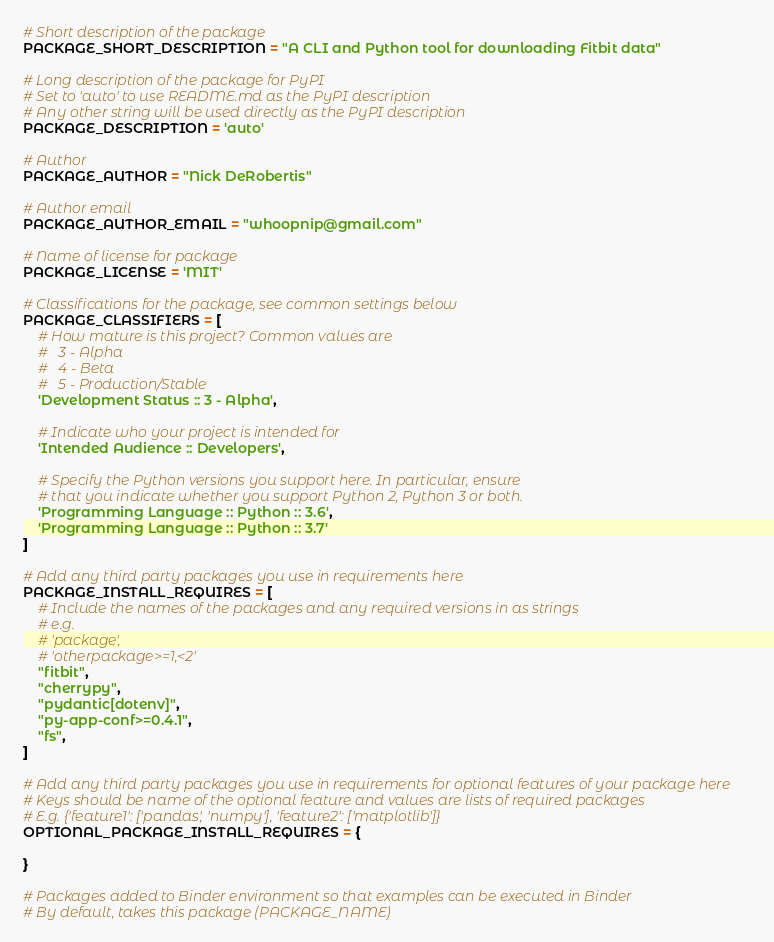<code> <loc_0><loc_0><loc_500><loc_500><_Python_>
# Short description of the package
PACKAGE_SHORT_DESCRIPTION = "A CLI and Python tool for downloading Fitbit data"

# Long description of the package for PyPI
# Set to 'auto' to use README.md as the PyPI description
# Any other string will be used directly as the PyPI description
PACKAGE_DESCRIPTION = 'auto'

# Author
PACKAGE_AUTHOR = "Nick DeRobertis"

# Author email
PACKAGE_AUTHOR_EMAIL = "whoopnip@gmail.com"

# Name of license for package
PACKAGE_LICENSE = 'MIT'

# Classifications for the package, see common settings below
PACKAGE_CLASSIFIERS = [
    # How mature is this project? Common values are
    #   3 - Alpha
    #   4 - Beta
    #   5 - Production/Stable
    'Development Status :: 3 - Alpha',

    # Indicate who your project is intended for
    'Intended Audience :: Developers',

    # Specify the Python versions you support here. In particular, ensure
    # that you indicate whether you support Python 2, Python 3 or both.
    'Programming Language :: Python :: 3.6',
    'Programming Language :: Python :: 3.7'
]

# Add any third party packages you use in requirements here
PACKAGE_INSTALL_REQUIRES = [
    # Include the names of the packages and any required versions in as strings
    # e.g.
    # 'package',
    # 'otherpackage>=1,<2'
    "fitbit",
    "cherrypy",
    "pydantic[dotenv]",
    "py-app-conf>=0.4.1",
    "fs",
]

# Add any third party packages you use in requirements for optional features of your package here
# Keys should be name of the optional feature and values are lists of required packages
# E.g. {'feature1': ['pandas', 'numpy'], 'feature2': ['matplotlib']}
OPTIONAL_PACKAGE_INSTALL_REQUIRES = {

}

# Packages added to Binder environment so that examples can be executed in Binder
# By default, takes this package (PACKAGE_NAME)</code> 